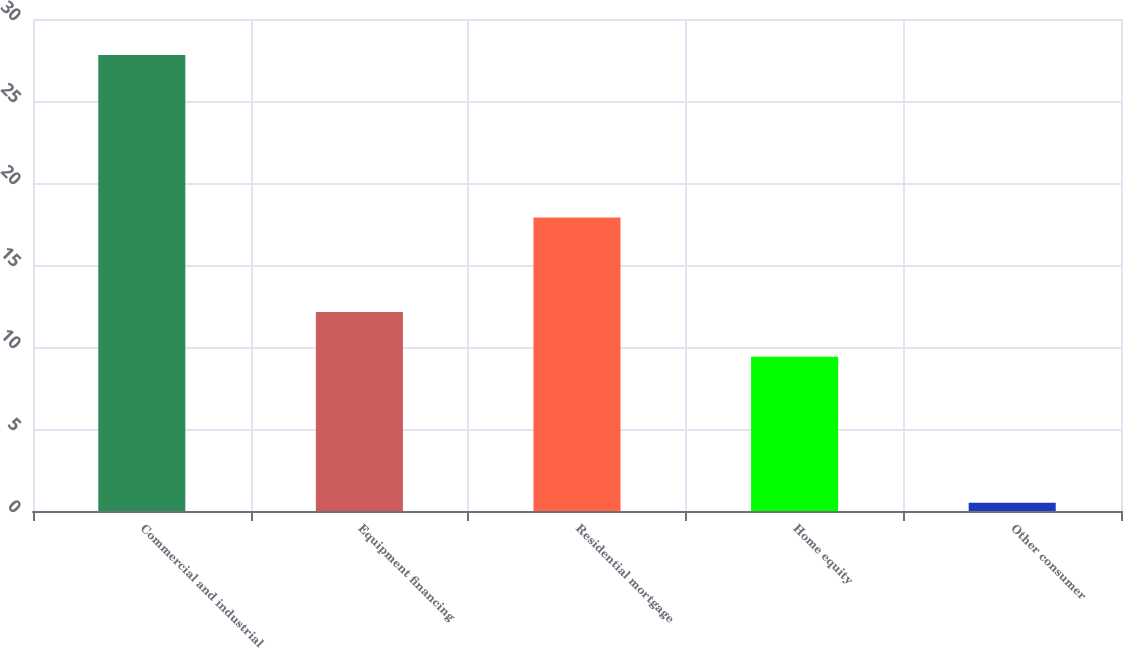Convert chart. <chart><loc_0><loc_0><loc_500><loc_500><bar_chart><fcel>Commercial and industrial<fcel>Equipment financing<fcel>Residential mortgage<fcel>Home equity<fcel>Other consumer<nl><fcel>27.8<fcel>12.13<fcel>17.9<fcel>9.4<fcel>0.5<nl></chart> 